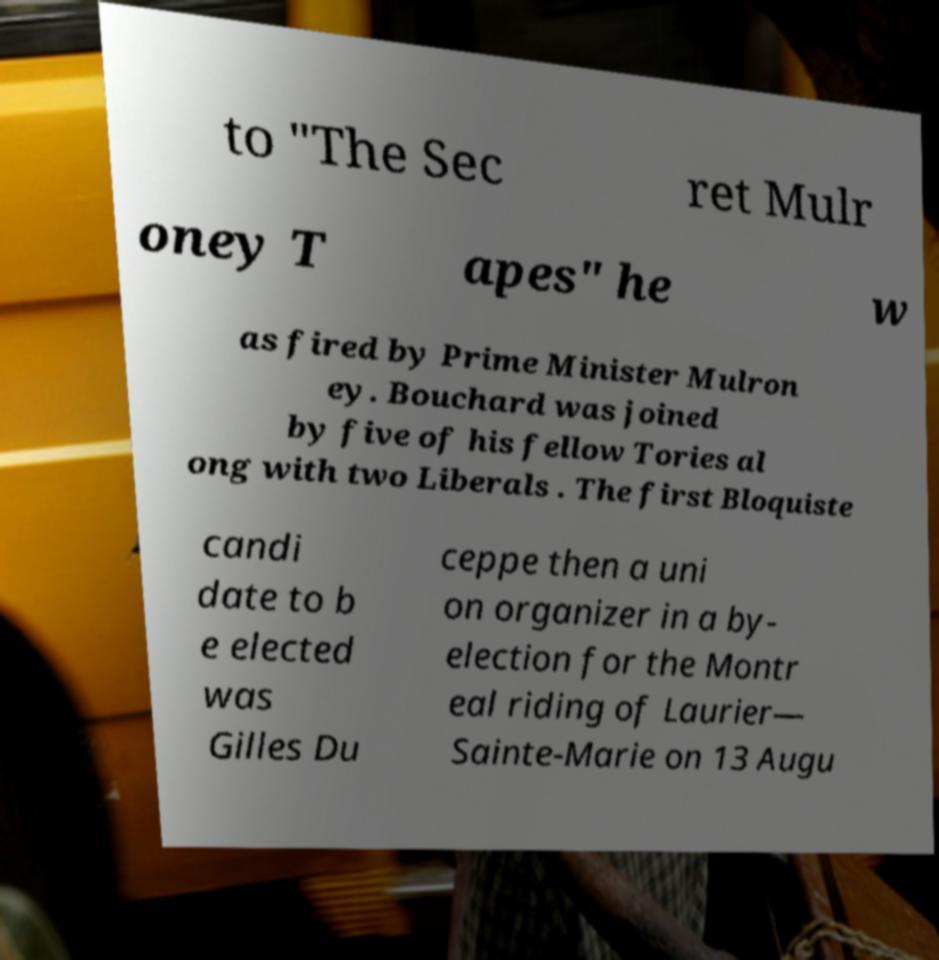Can you accurately transcribe the text from the provided image for me? to "The Sec ret Mulr oney T apes" he w as fired by Prime Minister Mulron ey. Bouchard was joined by five of his fellow Tories al ong with two Liberals . The first Bloquiste candi date to b e elected was Gilles Du ceppe then a uni on organizer in a by- election for the Montr eal riding of Laurier— Sainte-Marie on 13 Augu 